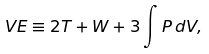<formula> <loc_0><loc_0><loc_500><loc_500>V E \equiv 2 T + W + 3 \int P \, d V ,</formula> 